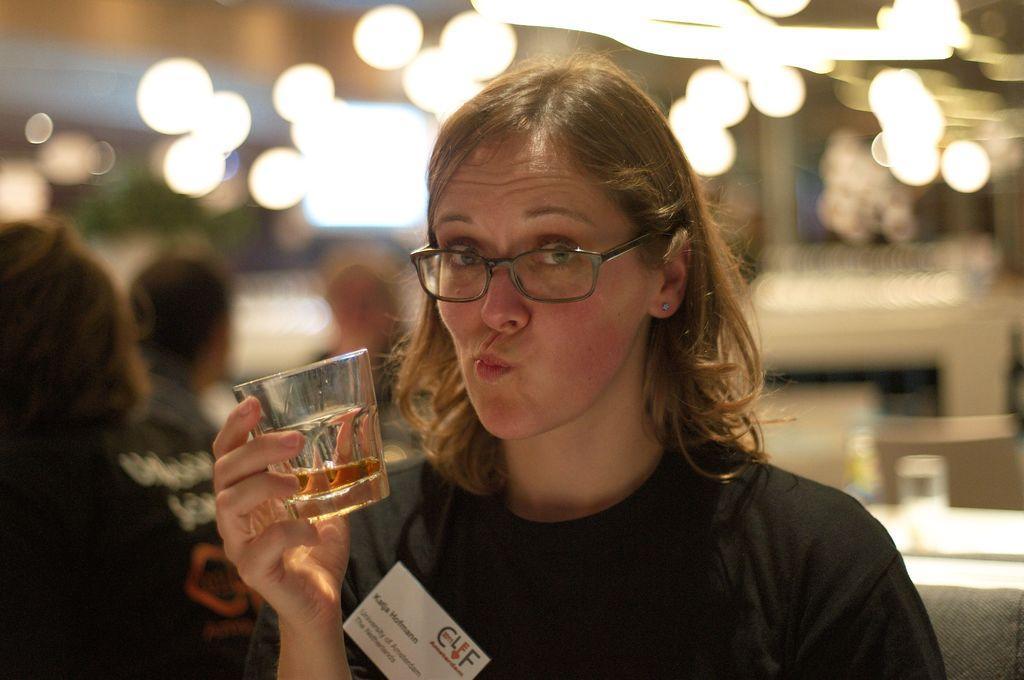Can you describe this image briefly? Four persons are there. This person holding glass with drink. On the background we can see lights. 